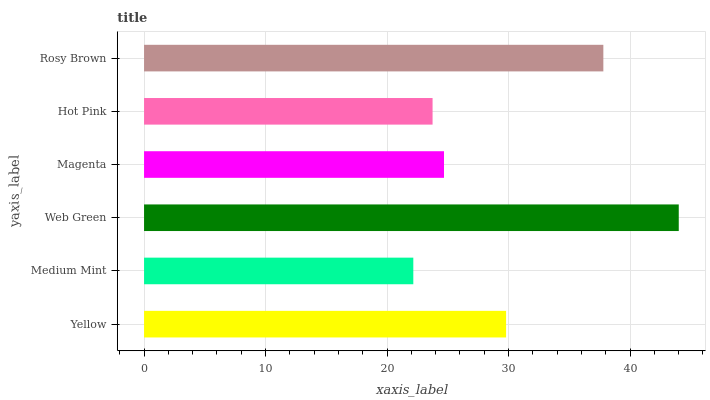Is Medium Mint the minimum?
Answer yes or no. Yes. Is Web Green the maximum?
Answer yes or no. Yes. Is Web Green the minimum?
Answer yes or no. No. Is Medium Mint the maximum?
Answer yes or no. No. Is Web Green greater than Medium Mint?
Answer yes or no. Yes. Is Medium Mint less than Web Green?
Answer yes or no. Yes. Is Medium Mint greater than Web Green?
Answer yes or no. No. Is Web Green less than Medium Mint?
Answer yes or no. No. Is Yellow the high median?
Answer yes or no. Yes. Is Magenta the low median?
Answer yes or no. Yes. Is Hot Pink the high median?
Answer yes or no. No. Is Yellow the low median?
Answer yes or no. No. 